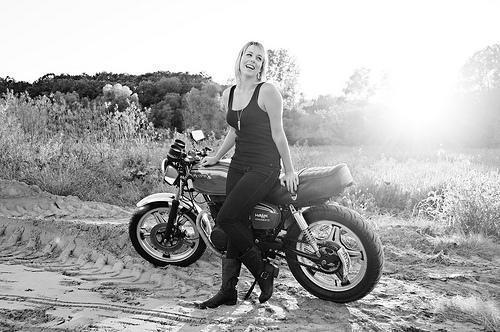How many tires are on this vehicle?
Give a very brief answer. 2. 